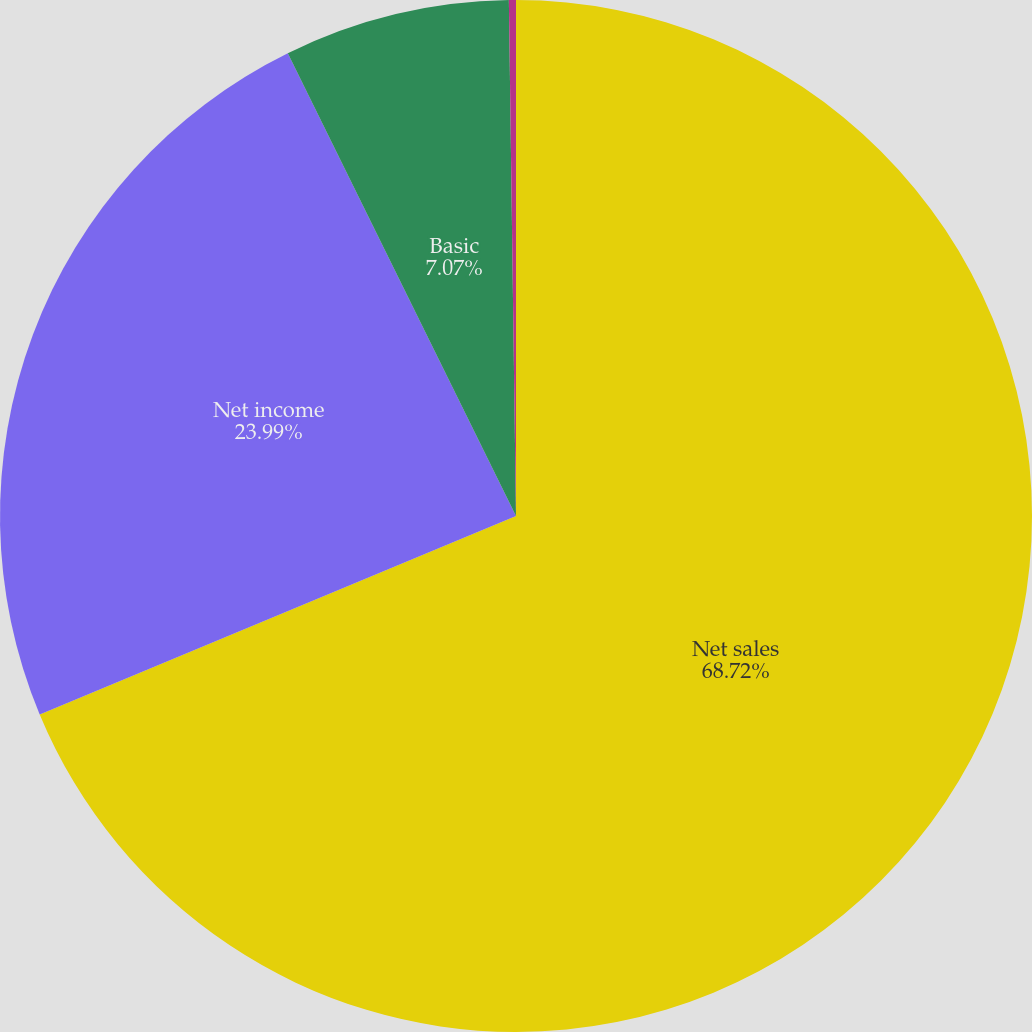<chart> <loc_0><loc_0><loc_500><loc_500><pie_chart><fcel>Net sales<fcel>Net income<fcel>Basic<fcel>Diluted<nl><fcel>68.71%<fcel>23.99%<fcel>7.07%<fcel>0.22%<nl></chart> 